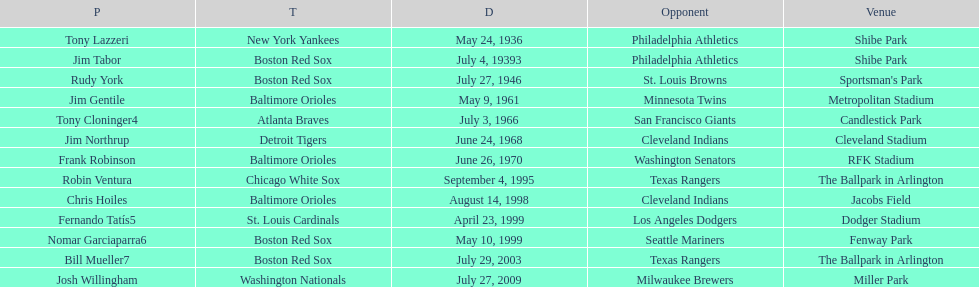What is the number of times a boston red sox player has had two grand slams in one game? 4. 